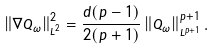<formula> <loc_0><loc_0><loc_500><loc_500>\left \| \nabla Q _ { \omega } \right \| _ { L ^ { 2 } } ^ { 2 } = \frac { d ( p - 1 ) } { 2 ( p + 1 ) } \left \| Q _ { \omega } \right \| _ { L ^ { p + 1 } } ^ { p + 1 } .</formula> 